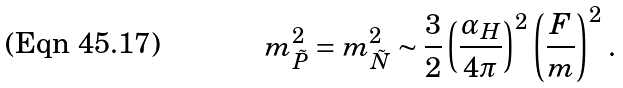Convert formula to latex. <formula><loc_0><loc_0><loc_500><loc_500>m _ { \tilde { P } } ^ { 2 } = m _ { \tilde { N } } ^ { 2 } \sim \frac { 3 } { 2 } \left ( \frac { \alpha _ { H } } { 4 \pi } \right ) ^ { 2 } \left ( \frac { F } { m } \right ) ^ { 2 } \, .</formula> 